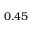Convert formula to latex. <formula><loc_0><loc_0><loc_500><loc_500>0 . 4 5</formula> 